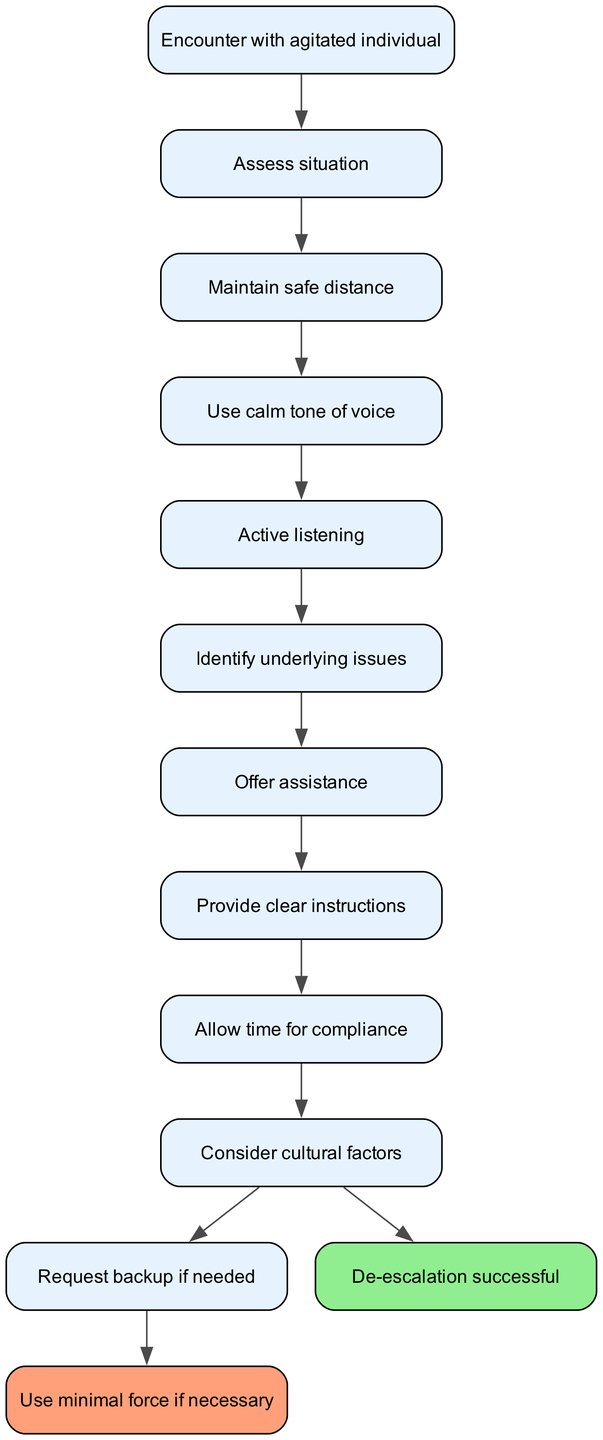What is the start node of the diagram? The start node, which initiates the clinical pathway, is explicitly labeled as "Encounter with agitated individual."
Answer: Encounter with agitated individual How many nodes are present in the diagram? By counting the nodes listed in the diagram, we find 12 distinct entries, including the start node.
Answer: 12 What color is the node for successful de-escalation? In the diagram, the node labeled "De-escalation successful" is colored light green, noted for its successful resolution aspect.
Answer: Light green What node directly follows "Use calm tone of voice"? Following the node "Use calm tone of voice," the next node is "Active listening," indicating the progression of steps in the protocol.
Answer: Active listening What are the options after "Consider cultural factors"? After reaching "Consider cultural factors," the pathway diverges to either "De-escalation successful" or "Request backup if needed," representing choices based on the situation.
Answer: De-escalation successful or Request backup if needed What is the last step if backup is requested? If backup is requested, the next proceeding step indicated is "Use minimal force if necessary," showing a response to continued aggression.
Answer: Use minimal force if necessary How does one proceed after identifying underlying issues? After identifying underlying issues, the next action in the protocol is to "Offer assistance," indicating a proactive approach to resolving the situation.
Answer: Offer assistance What step follows "Allow time for compliance"? The subsequent step after "Allow time for compliance" is "Consider cultural factors," which signifies the importance of understanding the individual's background in the de-escalation process.
Answer: Consider cultural factors What is the main purpose of the protocol described in the diagram? The primary purpose of the protocol is to de-escalate aggressive situations effectively while ensuring the safety of both personnel and individuals involved.
Answer: De-escalation 